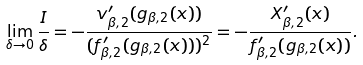<formula> <loc_0><loc_0><loc_500><loc_500>\lim _ { \delta \to 0 } \frac { I } { \delta } = - \frac { v _ { \beta , 2 } ^ { \prime } ( g _ { \beta , 2 } ( x ) ) } { ( f _ { \beta , 2 } ^ { \prime } ( g _ { \beta , 2 } ( x ) ) ) ^ { 2 } } = - \frac { X ^ { \prime } _ { \beta , 2 } ( x ) } { f _ { \beta , 2 } ^ { \prime } ( g _ { \beta , 2 } ( x ) ) } .</formula> 